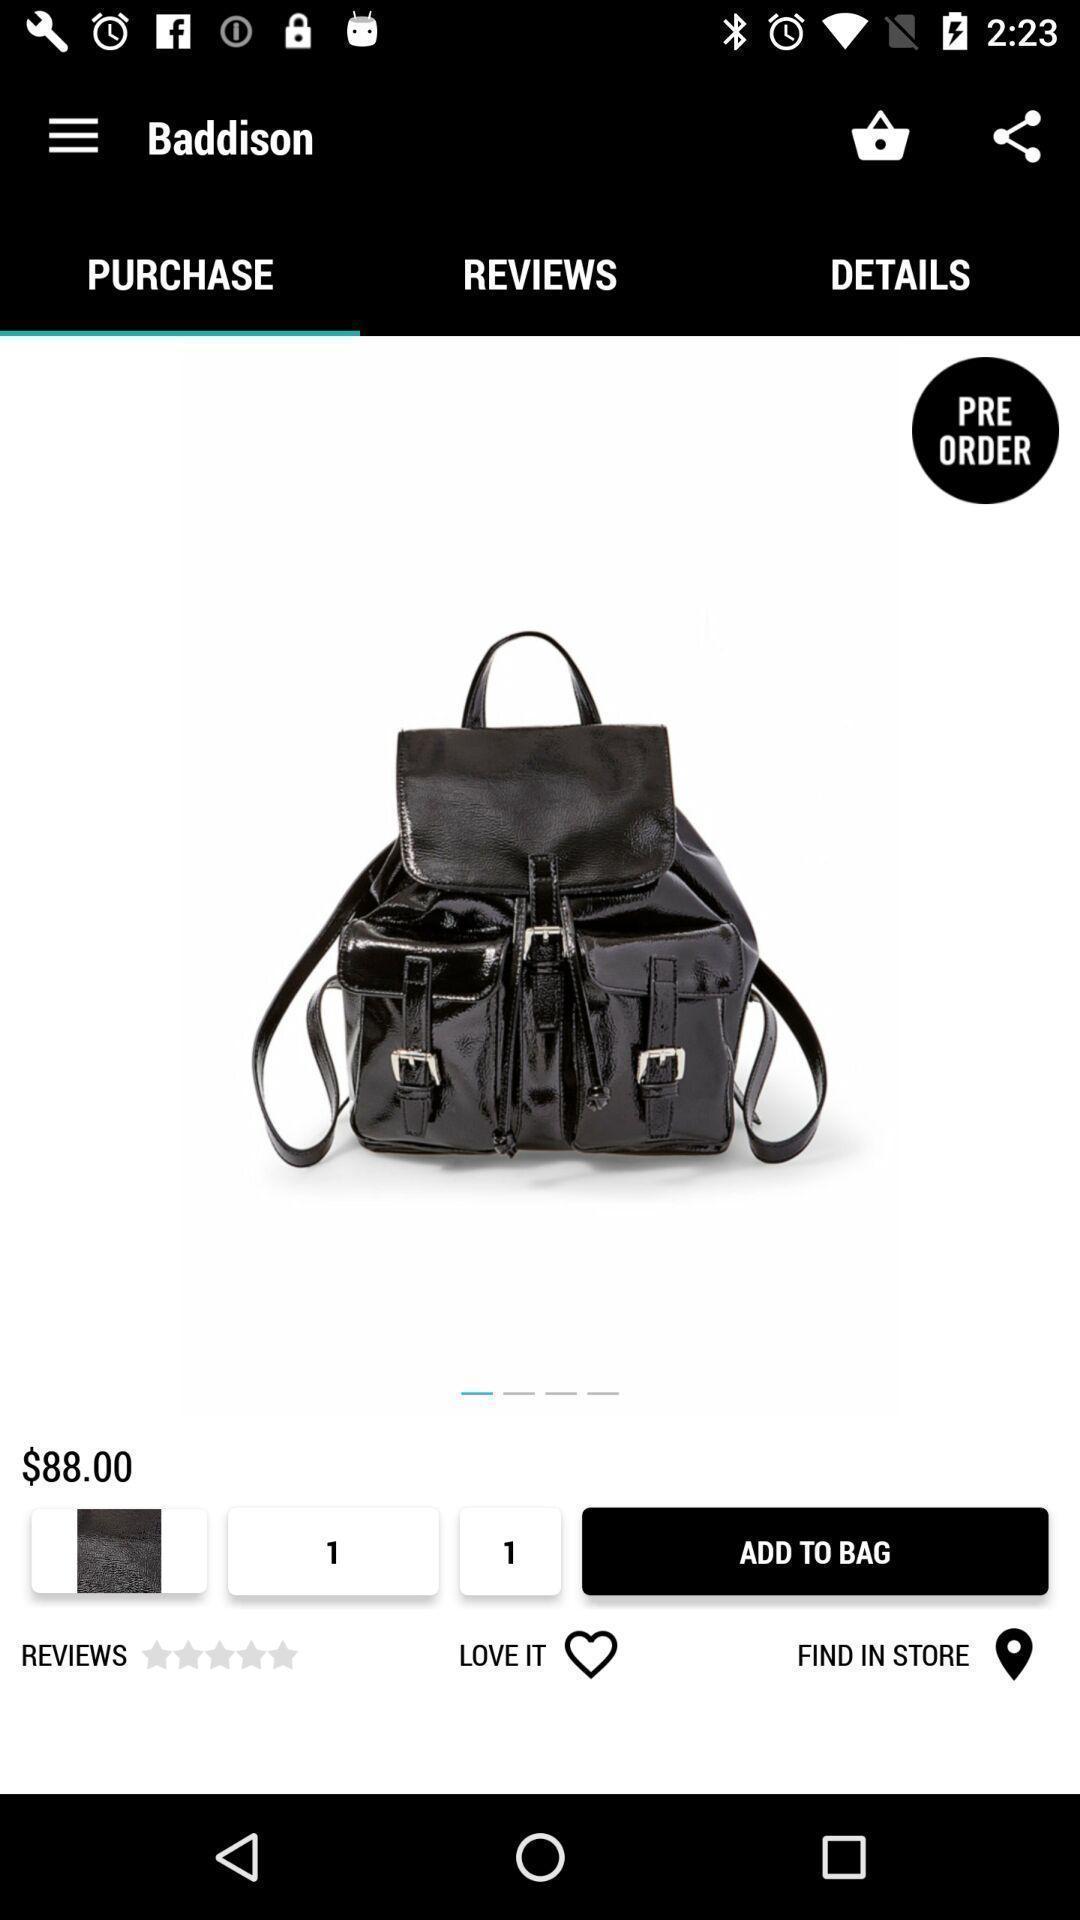Describe the key features of this screenshot. Screen displaying the product in a shopping app. 